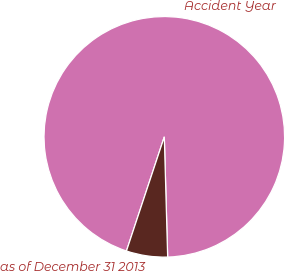Convert chart to OTSL. <chart><loc_0><loc_0><loc_500><loc_500><pie_chart><fcel>Accident Year<fcel>as of December 31 2013<nl><fcel>94.46%<fcel>5.54%<nl></chart> 